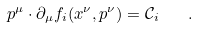Convert formula to latex. <formula><loc_0><loc_0><loc_500><loc_500>p ^ { \mu } \cdot \partial _ { \mu } f _ { i } ( x ^ { \nu } , p ^ { \nu } ) = \mathcal { C } _ { i } \quad .</formula> 